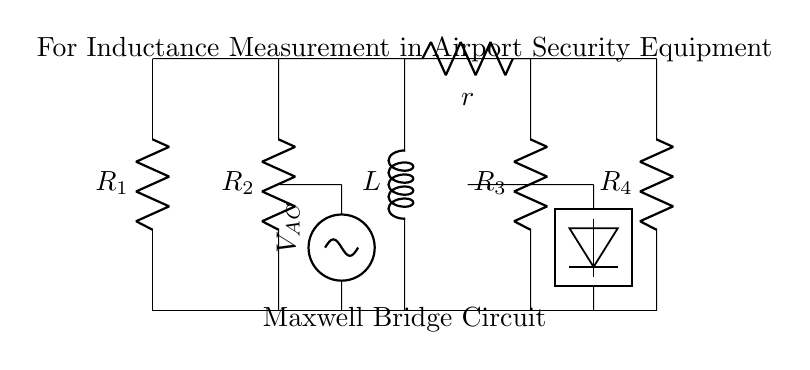What is the value of the component L in the circuit? The value of L represents the inductance being measured in the circuit. In the context of a Maxwell Bridge, this is the unknown inductance that we are aiming to balance with the resistors.
Answer: L What types of components are used in this circuit? The circuit includes resistors (R), an inductor (L), and an AC voltage source, as indicated by their symbols in the diagram. The presence of these components allows for precise measurement of inductance when the bridge is balanced.
Answer: Resistors, inductor, AC voltage source Which component is responsible for measuring the inductance? The inductor labeled L is the component whose inductance is being measured in this Maxwell Bridge configuration. Its value can be determined when the bridge reaches a balance condition.
Answer: L How many resistors are visible in the circuit? There are four resistors shown (labeled R1, R2, R3, R4) in the diagram. These resistors are strategically arranged to balance the circuit and help measure the unknown inductance accurately.
Answer: Four What is the purpose of the AC voltage source in the circuit? The AC voltage source provides an alternating current that is necessary for the operation of the bridge circuit. It creates a time-varying magnetic field in the inductor which facilitates the measurement of inductance by comparing it with the resistances in the circuit.
Answer: Measure inductance What condition must be met for the Maxwell Bridge to be considered balanced? The bridge is balanced when the voltage across the detector (which connects to the output of the bridge) is zero. At this point, the reactance of the inductor is equal to the resistance combination selected, indicating that the measured inductance can be calculated directly from the known resistor values.
Answer: Zero voltage across the detector 